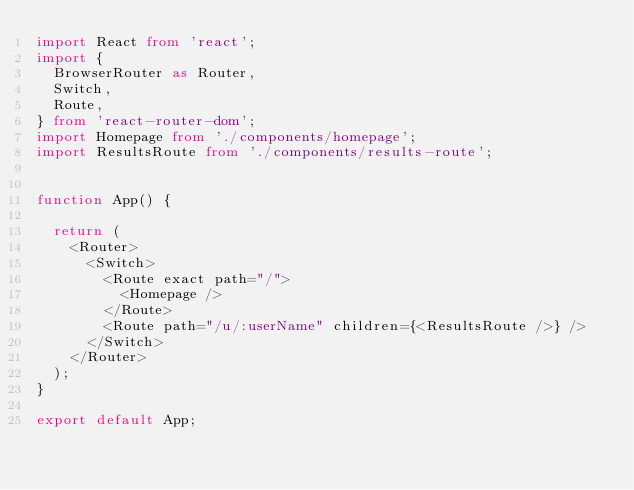Convert code to text. <code><loc_0><loc_0><loc_500><loc_500><_TypeScript_>import React from 'react';
import {
  BrowserRouter as Router,
  Switch,
  Route,
} from 'react-router-dom';
import Homepage from './components/homepage';
import ResultsRoute from './components/results-route';


function App() {

  return (
    <Router>
      <Switch>
        <Route exact path="/">
          <Homepage />
        </Route>
        <Route path="/u/:userName" children={<ResultsRoute />} />
      </Switch>
    </Router>
  );
}

export default App;
</code> 